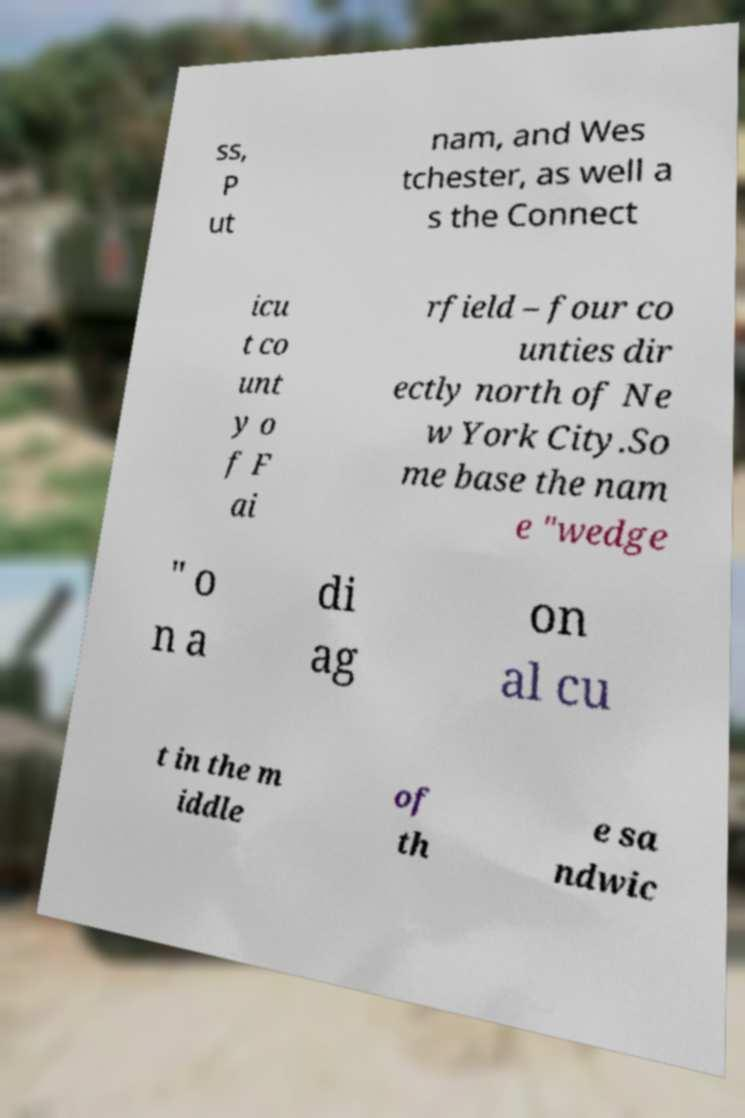Could you extract and type out the text from this image? ss, P ut nam, and Wes tchester, as well a s the Connect icu t co unt y o f F ai rfield – four co unties dir ectly north of Ne w York City.So me base the nam e "wedge " o n a di ag on al cu t in the m iddle of th e sa ndwic 